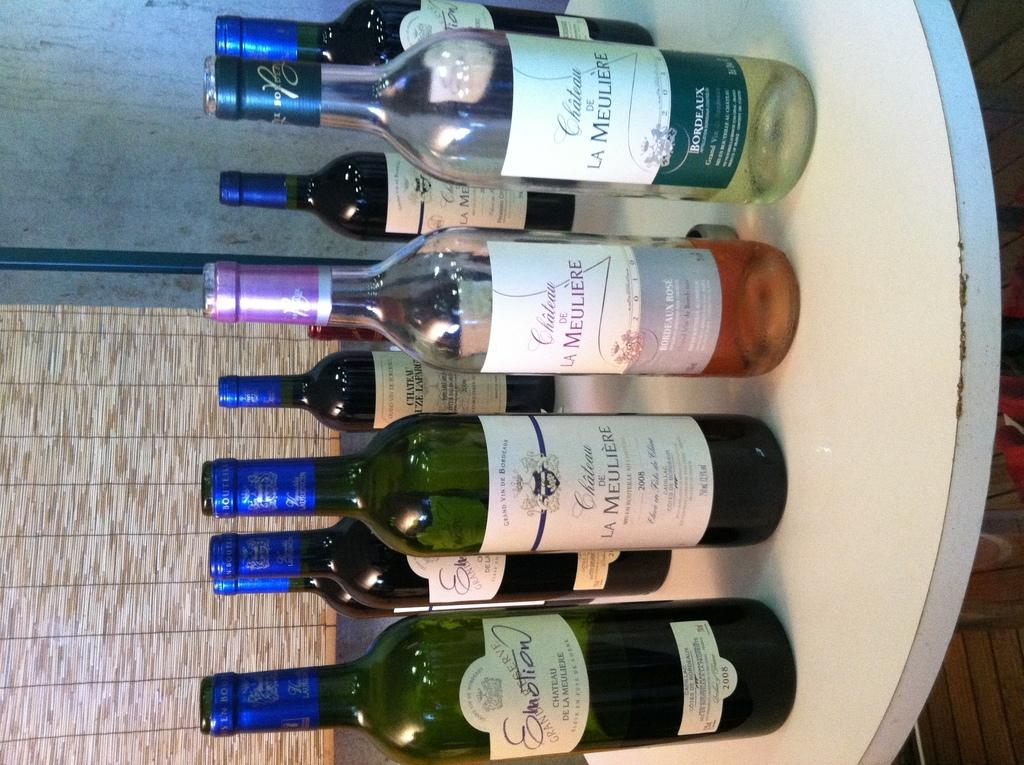What is on the table in the image? There is a group of bottles on the table. What can be seen on the bottles? The bottles have stickers on them. What is visible in the background of the image? There is a wall and a window in the background of the image. What type of flower is growing on the wall in the image? There is no flower growing on the wall in the image. How does the group of bottles express love in the image? The bottles do not express love in the image; they are simply bottles with stickers on them. 